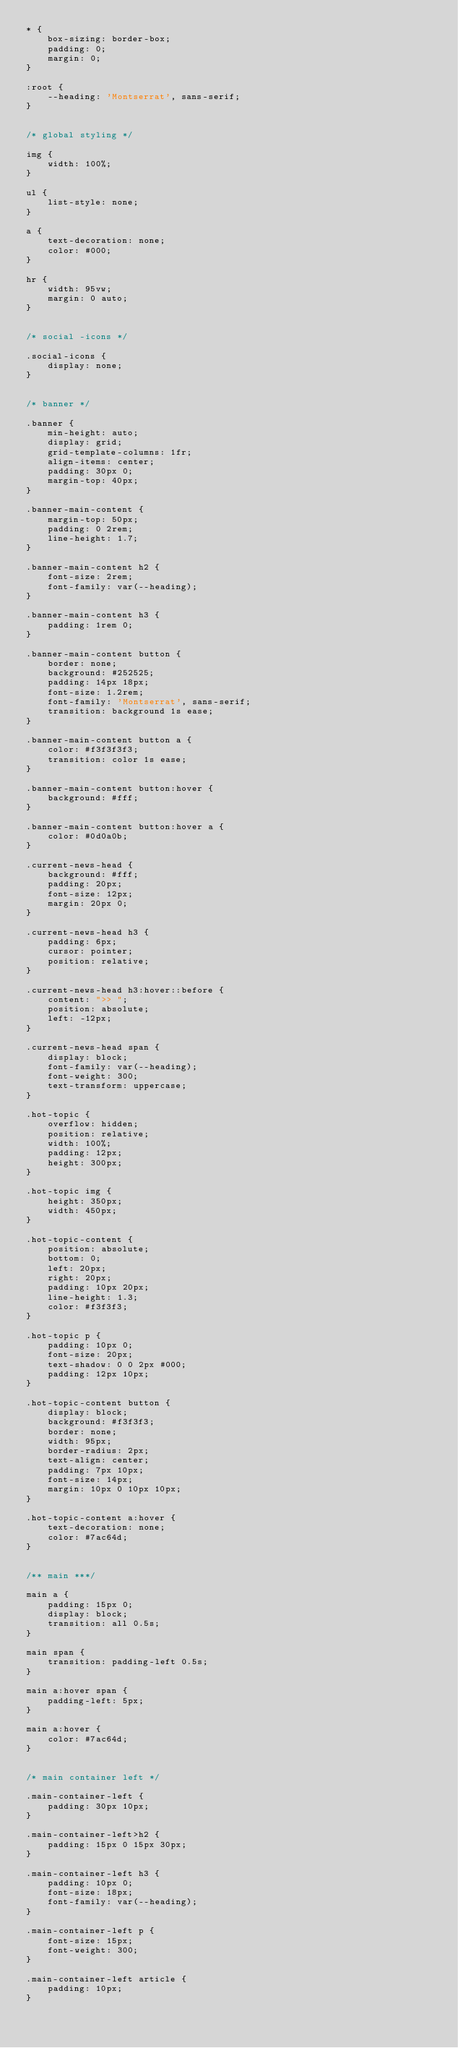Convert code to text. <code><loc_0><loc_0><loc_500><loc_500><_CSS_>* {
    box-sizing: border-box;
    padding: 0;
    margin: 0;
}

:root {
    --heading: 'Montserrat', sans-serif;
}


/* global styling */

img {
    width: 100%;
}

ul {
    list-style: none;
}

a {
    text-decoration: none;
    color: #000;
}

hr {
    width: 95vw;
    margin: 0 auto;
}


/* social -icons */

.social-icons {
    display: none;
}


/* banner */

.banner {
    min-height: auto;
    display: grid;
    grid-template-columns: 1fr;
    align-items: center;
    padding: 30px 0;
    margin-top: 40px;
}

.banner-main-content {
    margin-top: 50px;
    padding: 0 2rem;
    line-height: 1.7;
}

.banner-main-content h2 {
    font-size: 2rem;
    font-family: var(--heading);
}

.banner-main-content h3 {
    padding: 1rem 0;
}

.banner-main-content button {
    border: none;
    background: #252525;
    padding: 14px 18px;
    font-size: 1.2rem;
    font-family: 'Montserrat', sans-serif;
    transition: background 1s ease;
}

.banner-main-content button a {
    color: #f3f3f3f3;
    transition: color 1s ease;
}

.banner-main-content button:hover {
    background: #fff;
}

.banner-main-content button:hover a {
    color: #0d0a0b;
}

.current-news-head {
    background: #fff;
    padding: 20px;
    font-size: 12px;
    margin: 20px 0;
}

.current-news-head h3 {
    padding: 6px;
    cursor: pointer;
    position: relative;
}

.current-news-head h3:hover::before {
    content: ">> ";
    position: absolute;
    left: -12px;
}

.current-news-head span {
    display: block;
    font-family: var(--heading);
    font-weight: 300;
    text-transform: uppercase;
}

.hot-topic {
    overflow: hidden;
    position: relative;
    width: 100%;
    padding: 12px;
    height: 300px;
}

.hot-topic img {
    height: 350px;
    width: 450px;
}

.hot-topic-content {
    position: absolute;
    bottom: 0;
    left: 20px;
    right: 20px;
    padding: 10px 20px;
    line-height: 1.3;
    color: #f3f3f3;
}

.hot-topic p {
    padding: 10px 0;
    font-size: 20px;
    text-shadow: 0 0 2px #000;
    padding: 12px 10px;
}

.hot-topic-content button {
    display: block;
    background: #f3f3f3;
    border: none;
    width: 95px;
    border-radius: 2px;
    text-align: center;
    padding: 7px 10px;
    font-size: 14px;
    margin: 10px 0 10px 10px;
}

.hot-topic-content a:hover {
    text-decoration: none;
    color: #7ac64d;
}


/** main ***/

main a {
    padding: 15px 0;
    display: block;
    transition: all 0.5s;
}

main span {
    transition: padding-left 0.5s;
}

main a:hover span {
    padding-left: 5px;
}

main a:hover {
    color: #7ac64d;
}


/* main container left */

.main-container-left {
    padding: 30px 10px;
}

.main-container-left>h2 {
    padding: 15px 0 15px 30px;
}

.main-container-left h3 {
    padding: 10px 0;
    font-size: 18px;
    font-family: var(--heading);
}

.main-container-left p {
    font-size: 15px;
    font-weight: 300;
}

.main-container-left article {
    padding: 10px;
}
</code> 